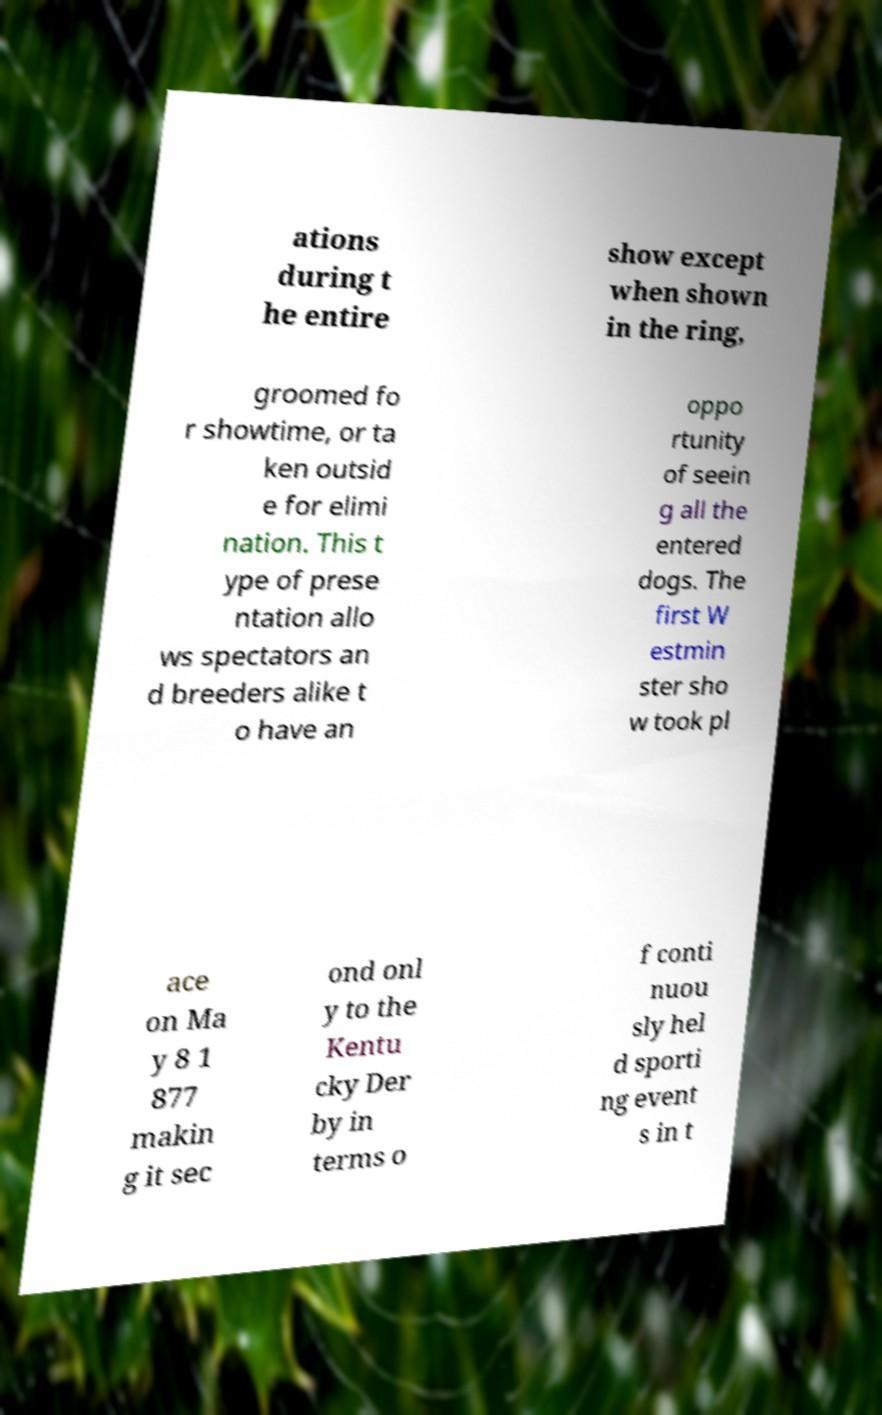For documentation purposes, I need the text within this image transcribed. Could you provide that? ations during t he entire show except when shown in the ring, groomed fo r showtime, or ta ken outsid e for elimi nation. This t ype of prese ntation allo ws spectators an d breeders alike t o have an oppo rtunity of seein g all the entered dogs. The first W estmin ster sho w took pl ace on Ma y 8 1 877 makin g it sec ond onl y to the Kentu cky Der by in terms o f conti nuou sly hel d sporti ng event s in t 